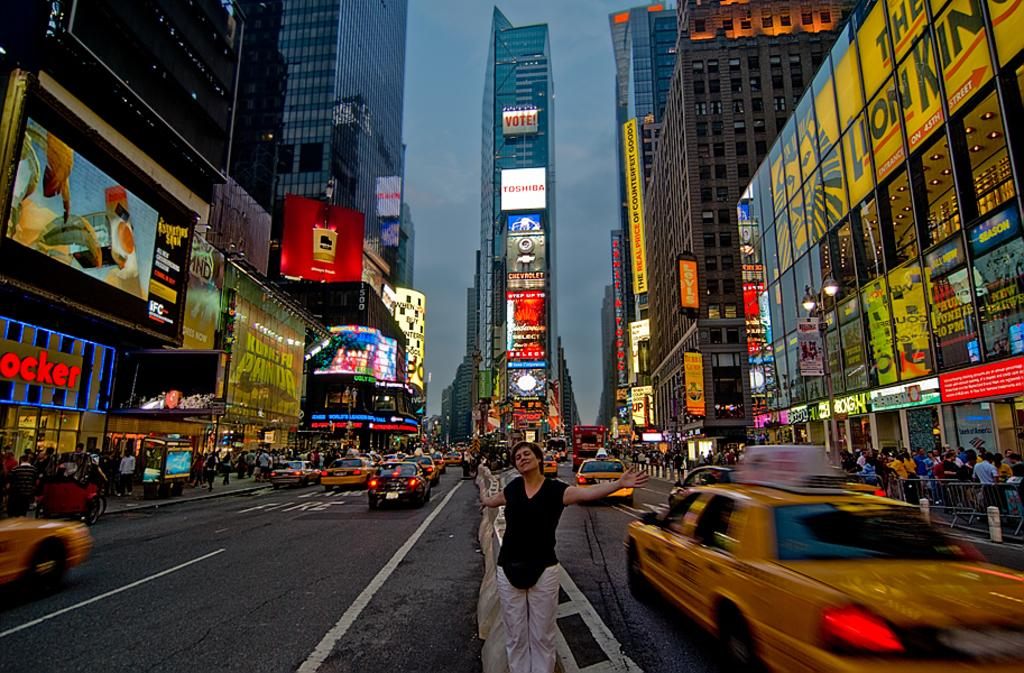<image>
Give a short and clear explanation of the subsequent image. A busy street has a banner on yellow advertising the Lion King.. 